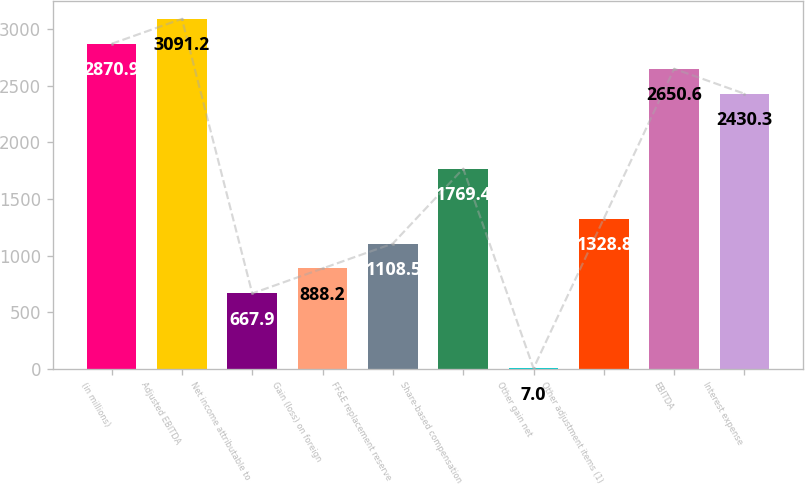Convert chart. <chart><loc_0><loc_0><loc_500><loc_500><bar_chart><fcel>(in millions)<fcel>Adjusted EBITDA<fcel>Net income attributable to<fcel>Gain (loss) on foreign<fcel>FF&E replacement reserve<fcel>Share-based compensation<fcel>Other gain net<fcel>Other adjustment items (1)<fcel>EBITDA<fcel>Interest expense<nl><fcel>2870.9<fcel>3091.2<fcel>667.9<fcel>888.2<fcel>1108.5<fcel>1769.4<fcel>7<fcel>1328.8<fcel>2650.6<fcel>2430.3<nl></chart> 